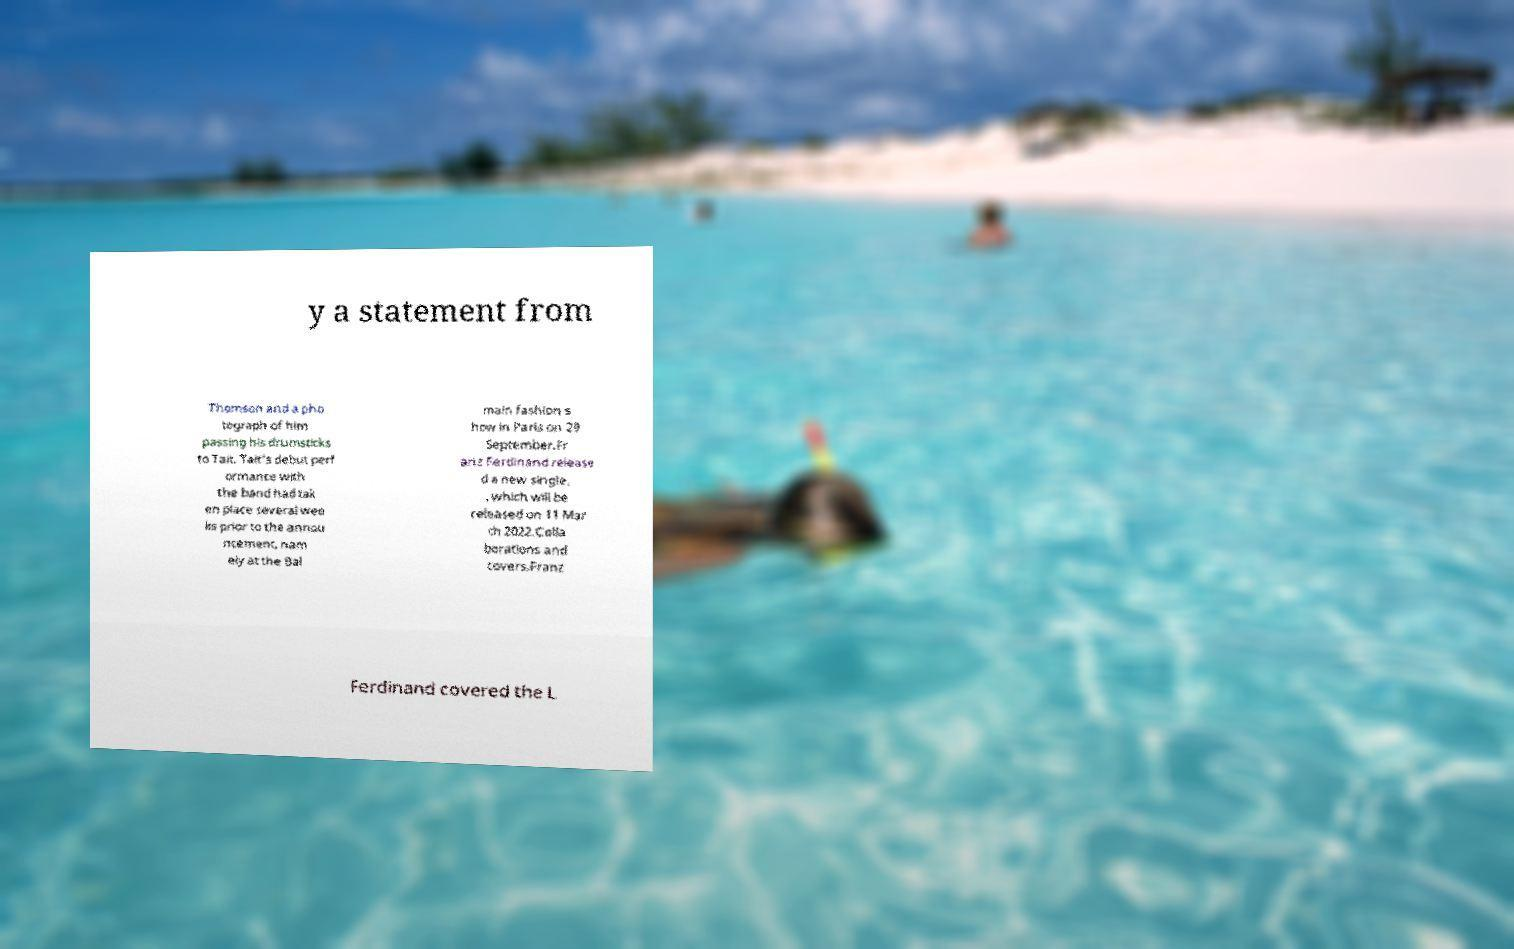Could you extract and type out the text from this image? y a statement from Thomson and a pho tograph of him passing his drumsticks to Tait. Tait's debut perf ormance with the band had tak en place several wee ks prior to the annou ncement, nam ely at the Bal main fashion s how in Paris on 29 September.Fr anz Ferdinand release d a new single, , which will be released on 11 Mar ch 2022.Colla borations and covers.Franz Ferdinand covered the L 